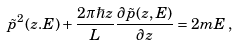<formula> <loc_0><loc_0><loc_500><loc_500>\tilde { p } ^ { 2 } ( z . E ) + \frac { 2 \pi \hbar { z } } { L } \frac { \partial \tilde { p } ( z , E ) } { \partial z } = 2 m E \, ,</formula> 